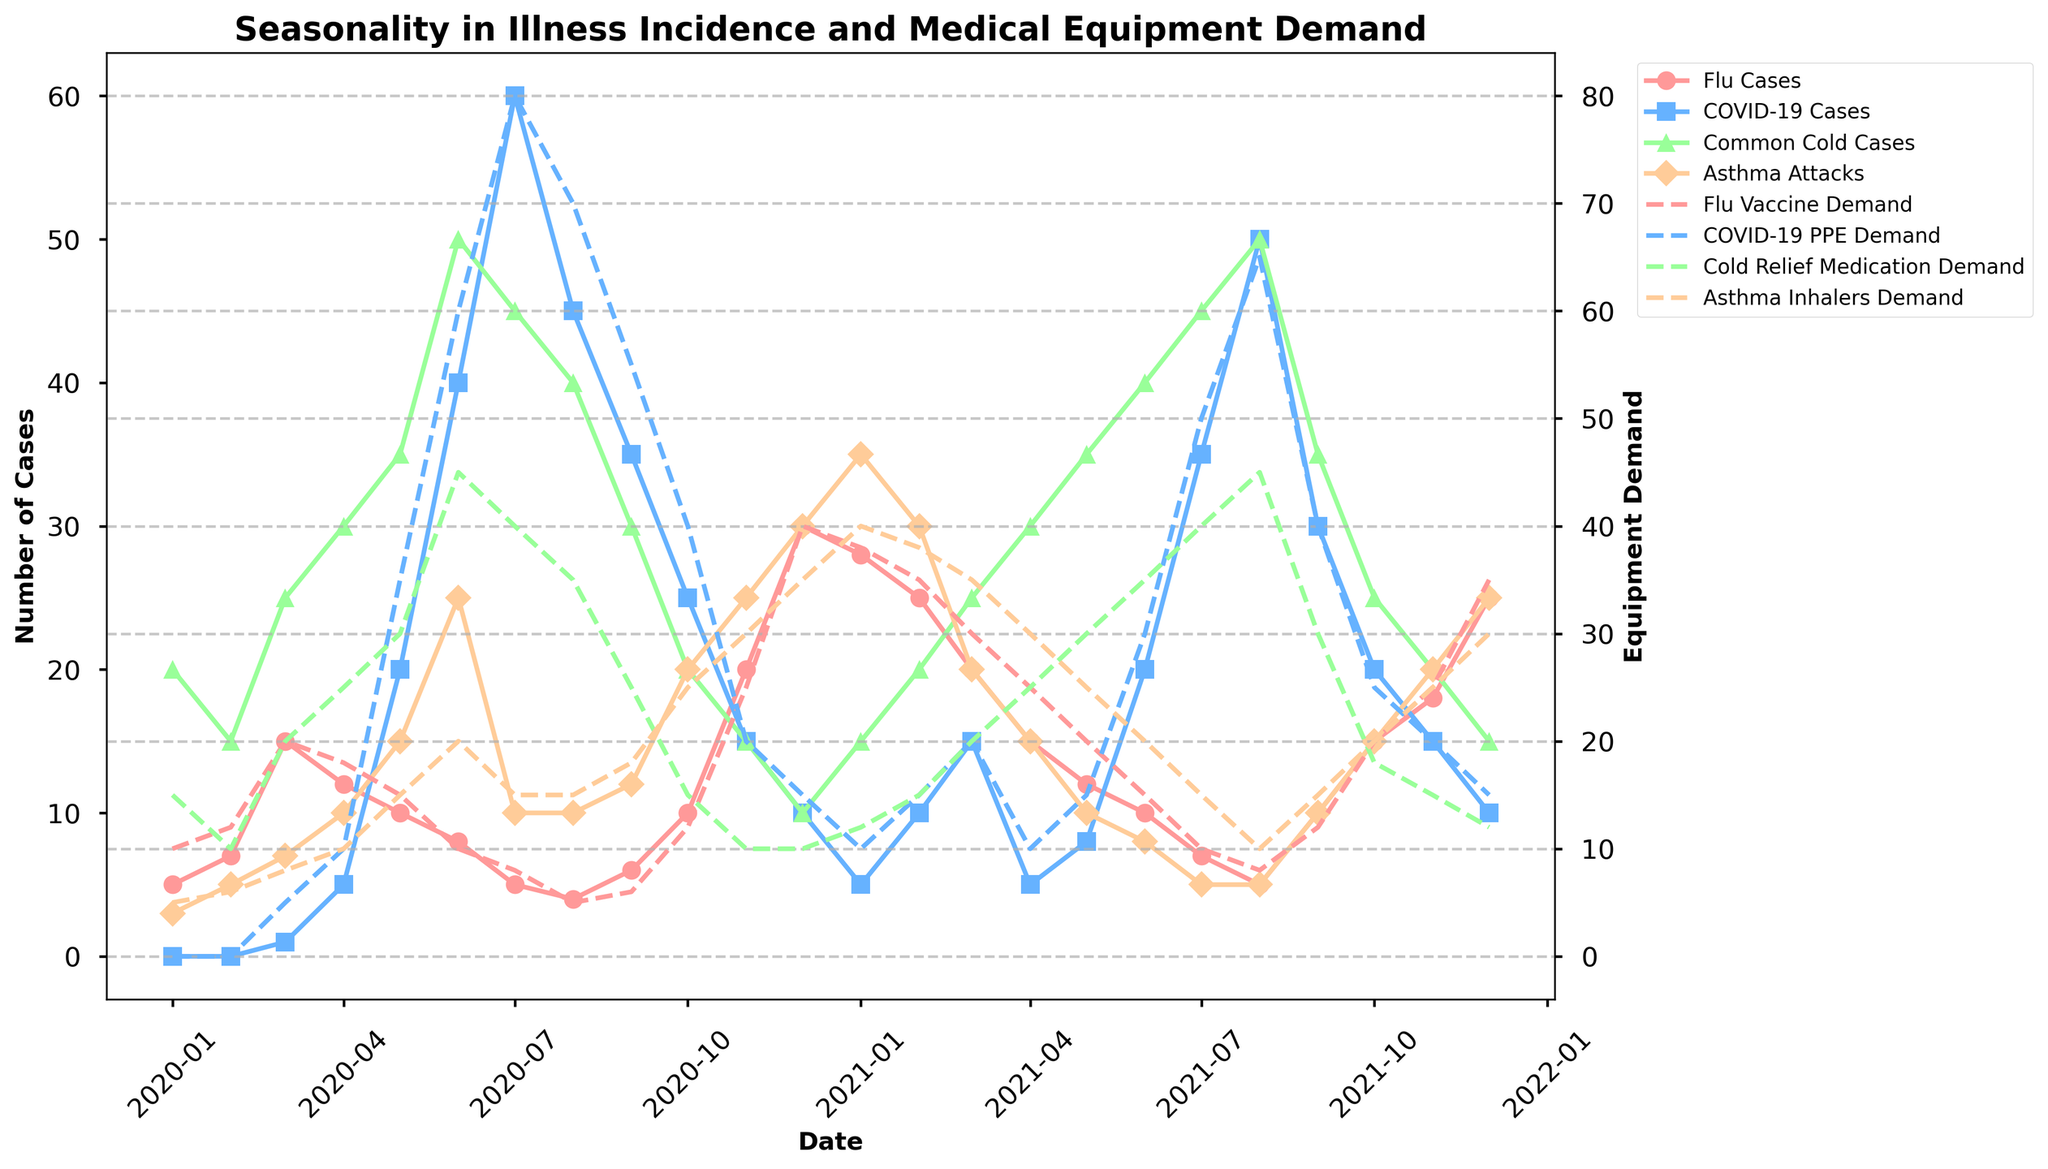What's the title of the figure? The title is displayed at the top of the figure. It describes the overall content and purpose of the figure.
Answer: Seasonality in Illness Incidence and Medical Equipment Demand What are the two y-axis labels, and what do they represent? The left y-axis represents the number of illness cases, and the right y-axis represents the medical equipment demand. These labels are usually placed vertically on either side of the figure.
Answer: Number of Cases, Equipment Demand Which illness has the highest incidence in March 2020? To find this, locate March 2020 on the x-axis and compare the heights of the lines for different illnesses. The line with the highest point indicates the illness with the highest incidence.
Answer: Common Cold Cases During which month in 2020 did COVID-19 cases peak? Look across the COVID-19 cases' line and find the month where it reaches its highest point in 2020.
Answer: July 2020 How does the demand for Cold Relief Medication change from June 2020 to July 2020? Identify the points for Cold Relief Medication demand in June and July 2020, then compare their values. Subtract or compare to see if there's an increase or decrease.
Answer: It decreases Which month shows the highest demand for Flu Vaccine? Follow the Flu Vaccine Demand line and find the peak value point throughout the months displayed.
Answer: December 2020 How many data points are there for each illness and equipment demand? Count the number of data points visible for each line on the plot. Each point represents a month from January 2020 to December 2021.
Answer: 24 Compare the number of asthma attacks in May 2020 and May 2021. Which month had higher cases? Locate May 2020 and May 2021 on the x-axis and then compare the values of the Asthma Attacks line in these two months.
Answer: May 2021 During which period did the demand for COVID-19 PPE see a continuous increase? Look for a span of months where the COVID-19 PPE Demand line consistently goes upwards without any dips.
Answer: March 2020 to August 2021 What can be inferred about the relationship between flu cases and flu vaccine demand from the plot? Compare the trends of the Flu Cases line with that of the Flu Vaccine Demand line. Check if peaks in flu cases correspond to peaks in vaccine demand.
Answer: As flu cases increase, flu vaccine demand generally increases 